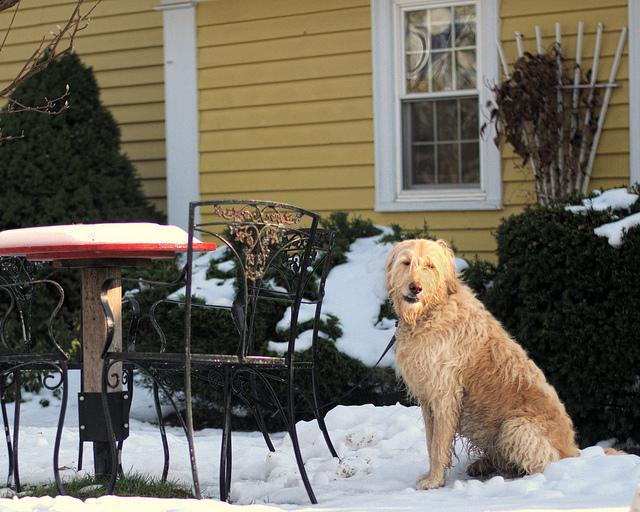What famous animal does this one most closely resemble? Please explain your reasoning. benji. The dog in the snow is very similar to the dog in the movie benji. 